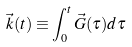<formula> <loc_0><loc_0><loc_500><loc_500>\vec { k } ( t ) \equiv \int _ { 0 } ^ { t } \vec { G } ( \tau ) d \tau</formula> 